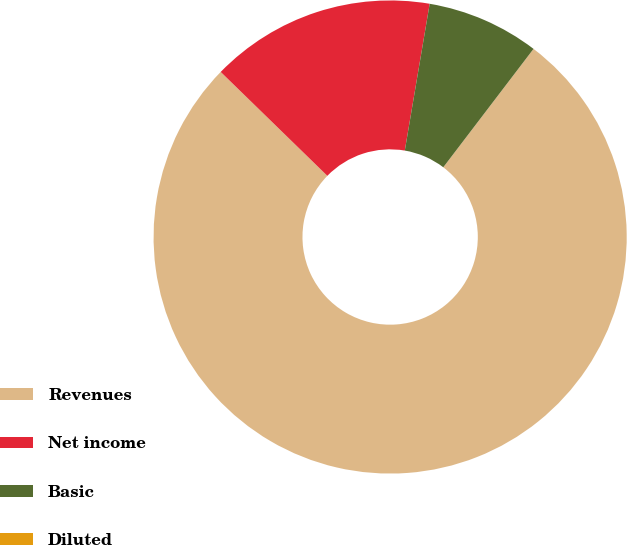Convert chart to OTSL. <chart><loc_0><loc_0><loc_500><loc_500><pie_chart><fcel>Revenues<fcel>Net income<fcel>Basic<fcel>Diluted<nl><fcel>76.92%<fcel>15.38%<fcel>7.69%<fcel>0.0%<nl></chart> 